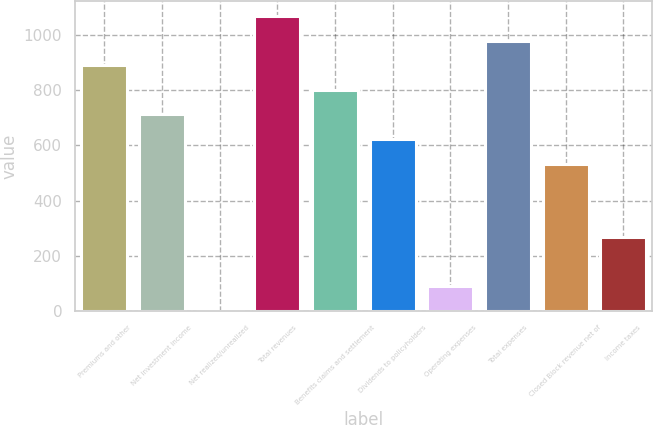Convert chart. <chart><loc_0><loc_0><loc_500><loc_500><bar_chart><fcel>Premiums and other<fcel>Net investment income<fcel>Net realized/unrealized<fcel>Total revenues<fcel>Benefits claims and settlement<fcel>Dividends to policyholders<fcel>Operating expenses<fcel>Total expenses<fcel>Closed Block revenue net of<fcel>Income taxes<nl><fcel>889<fcel>711.38<fcel>0.9<fcel>1066.62<fcel>800.19<fcel>622.57<fcel>89.71<fcel>977.81<fcel>533.76<fcel>267.33<nl></chart> 